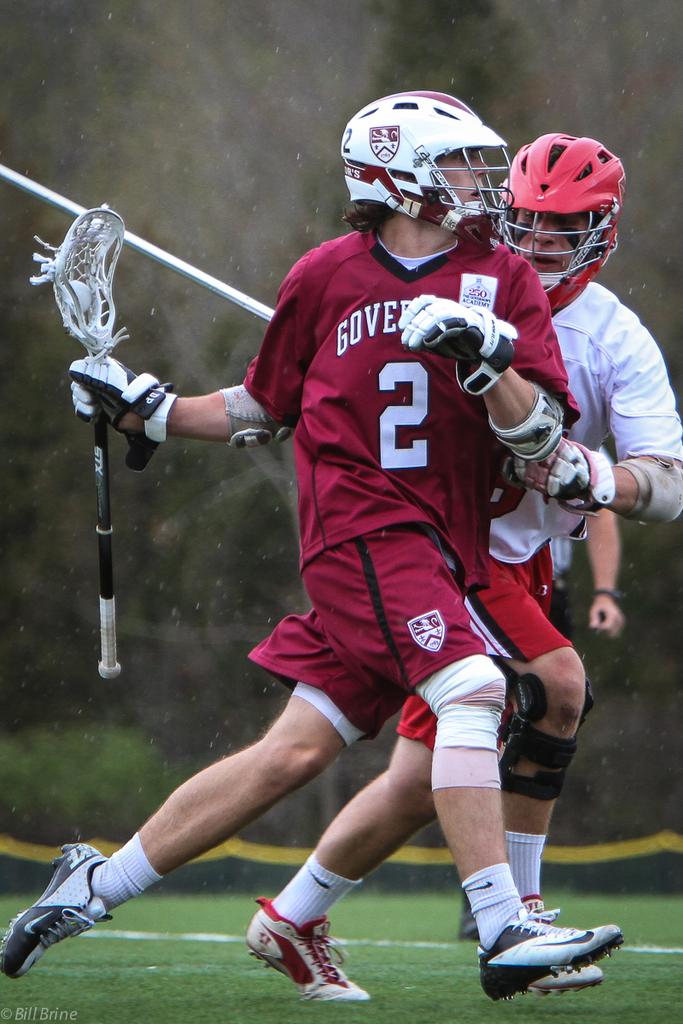What is the red players jersey number?
Offer a very short reply. 2. 